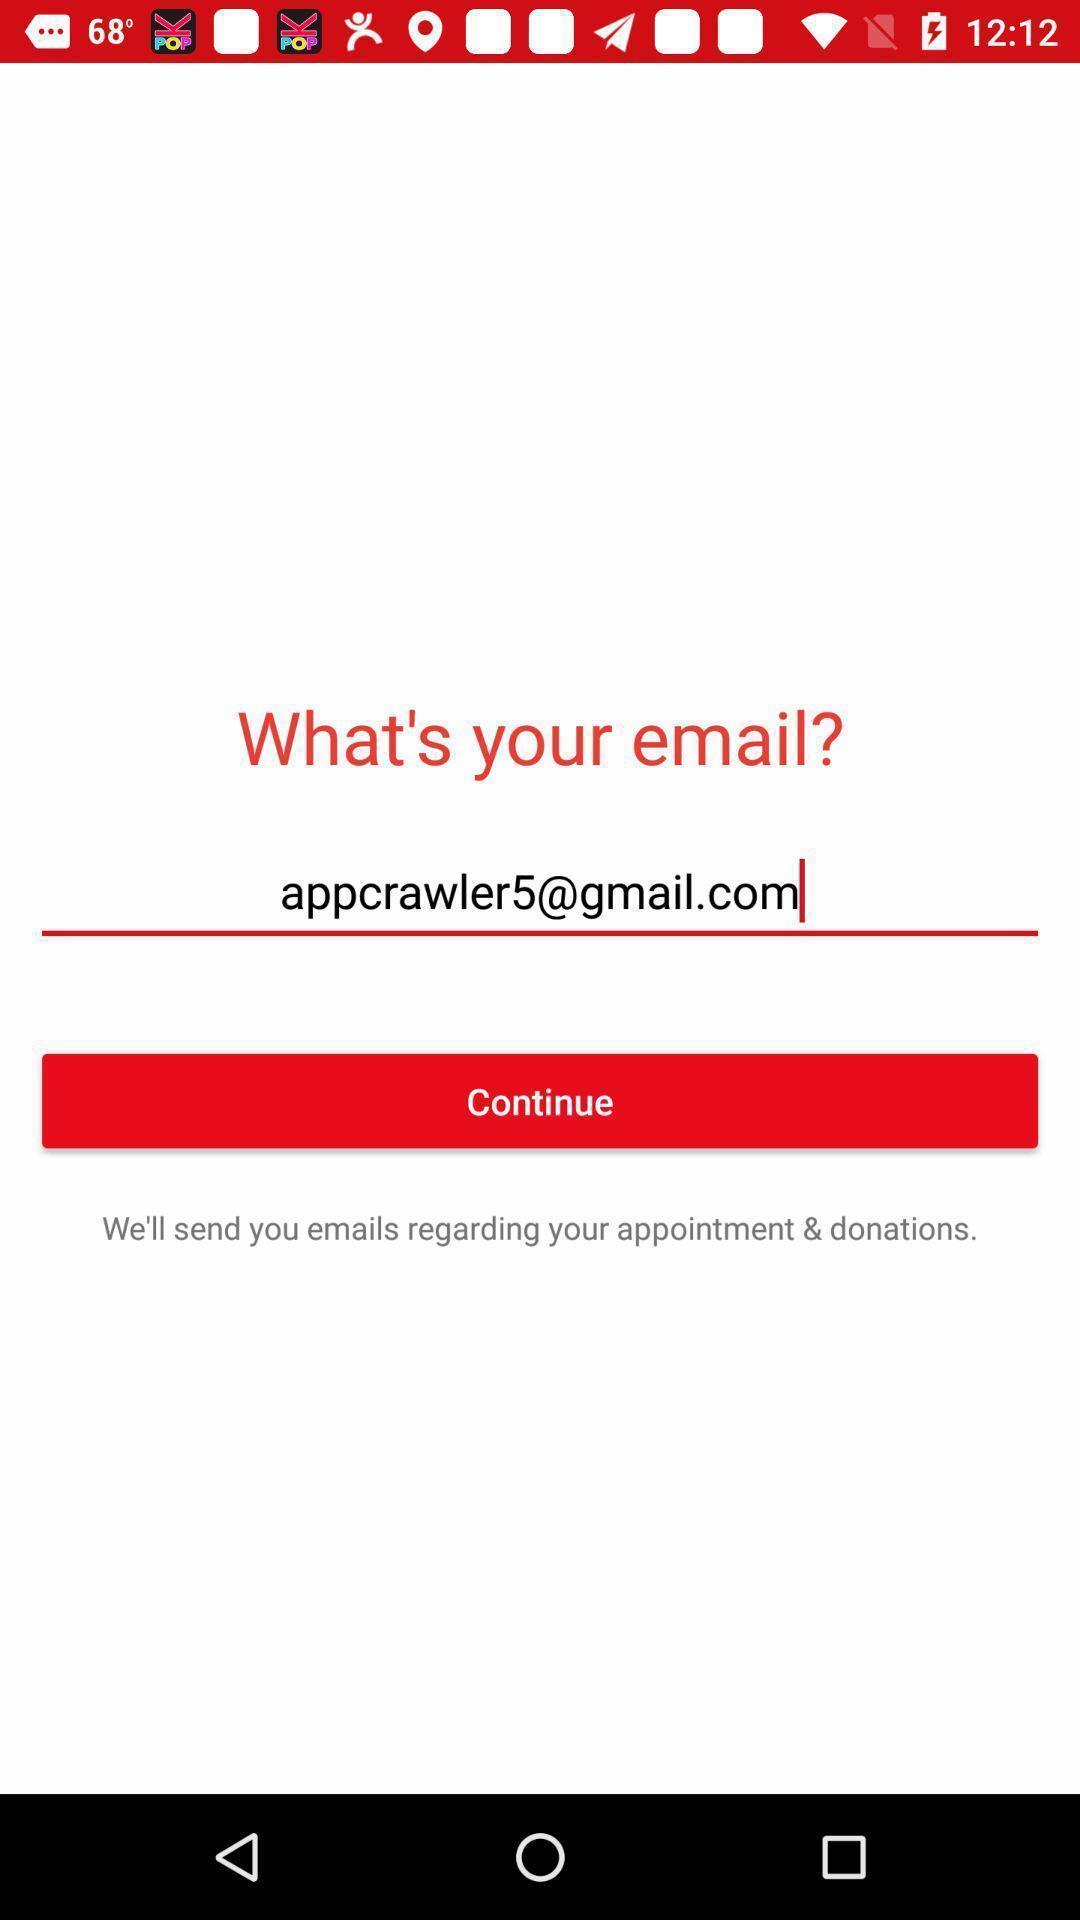Describe the content in this image. Page is showing what 's your email with continue option. 